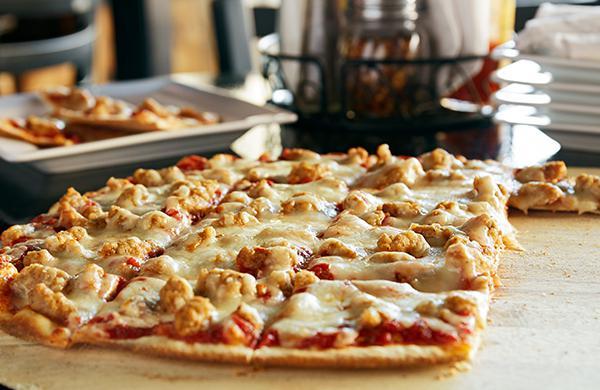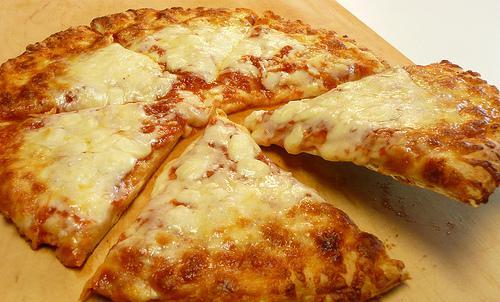The first image is the image on the left, the second image is the image on the right. For the images shown, is this caption "In one of the images the pizza is cut into squares." true? Answer yes or no. Yes. The first image is the image on the left, the second image is the image on the right. Evaluate the accuracy of this statement regarding the images: "One image shows a round pizza cut in triangular 'pie' slices, with a slice at least partly off, and the other image features a pizza cut in squares.". Is it true? Answer yes or no. Yes. 